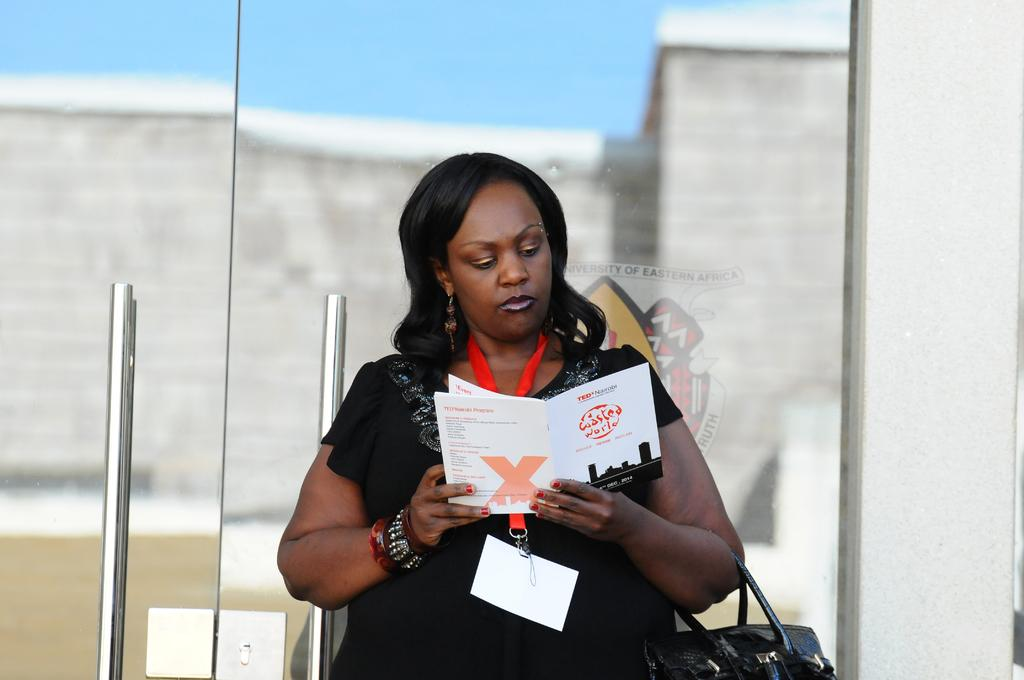Who is the main subject in the image? There is a woman in the image. What is the woman doing in the image? The woman is reading a book. What type of doors can be seen in the image? There are glass doors with metal handle bars in the image. Where are the glass doors located in relation to the woman? The glass doors are behind the woman. What is beside the glass doors in the image? There is a wall beside the door. How does the woman cook the bead in the image? There is no bead or cooking activity present in the image. The woman is reading a book, and there are no cooking elements or ingredients shown. 